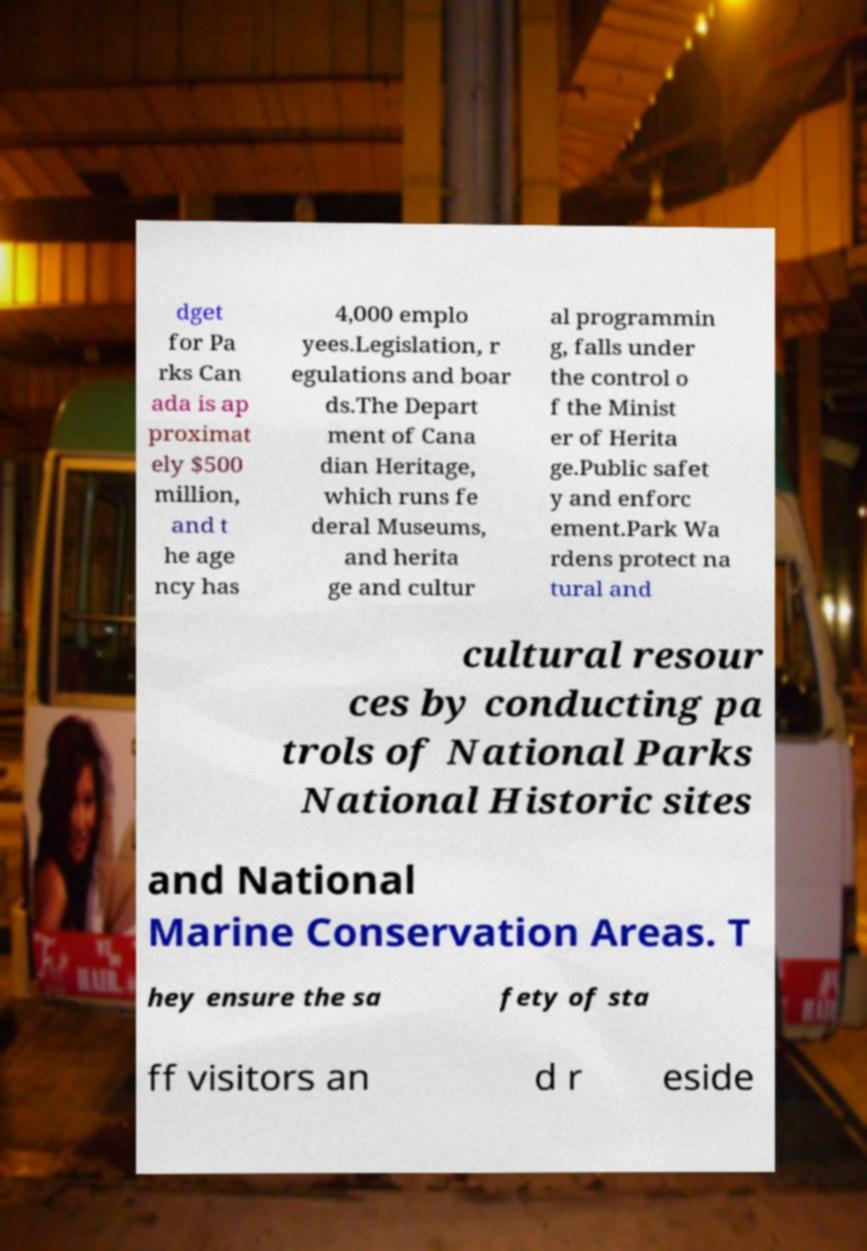Please read and relay the text visible in this image. What does it say? dget for Pa rks Can ada is ap proximat ely $500 million, and t he age ncy has 4,000 emplo yees.Legislation, r egulations and boar ds.The Depart ment of Cana dian Heritage, which runs fe deral Museums, and herita ge and cultur al programmin g, falls under the control o f the Minist er of Herita ge.Public safet y and enforc ement.Park Wa rdens protect na tural and cultural resour ces by conducting pa trols of National Parks National Historic sites and National Marine Conservation Areas. T hey ensure the sa fety of sta ff visitors an d r eside 